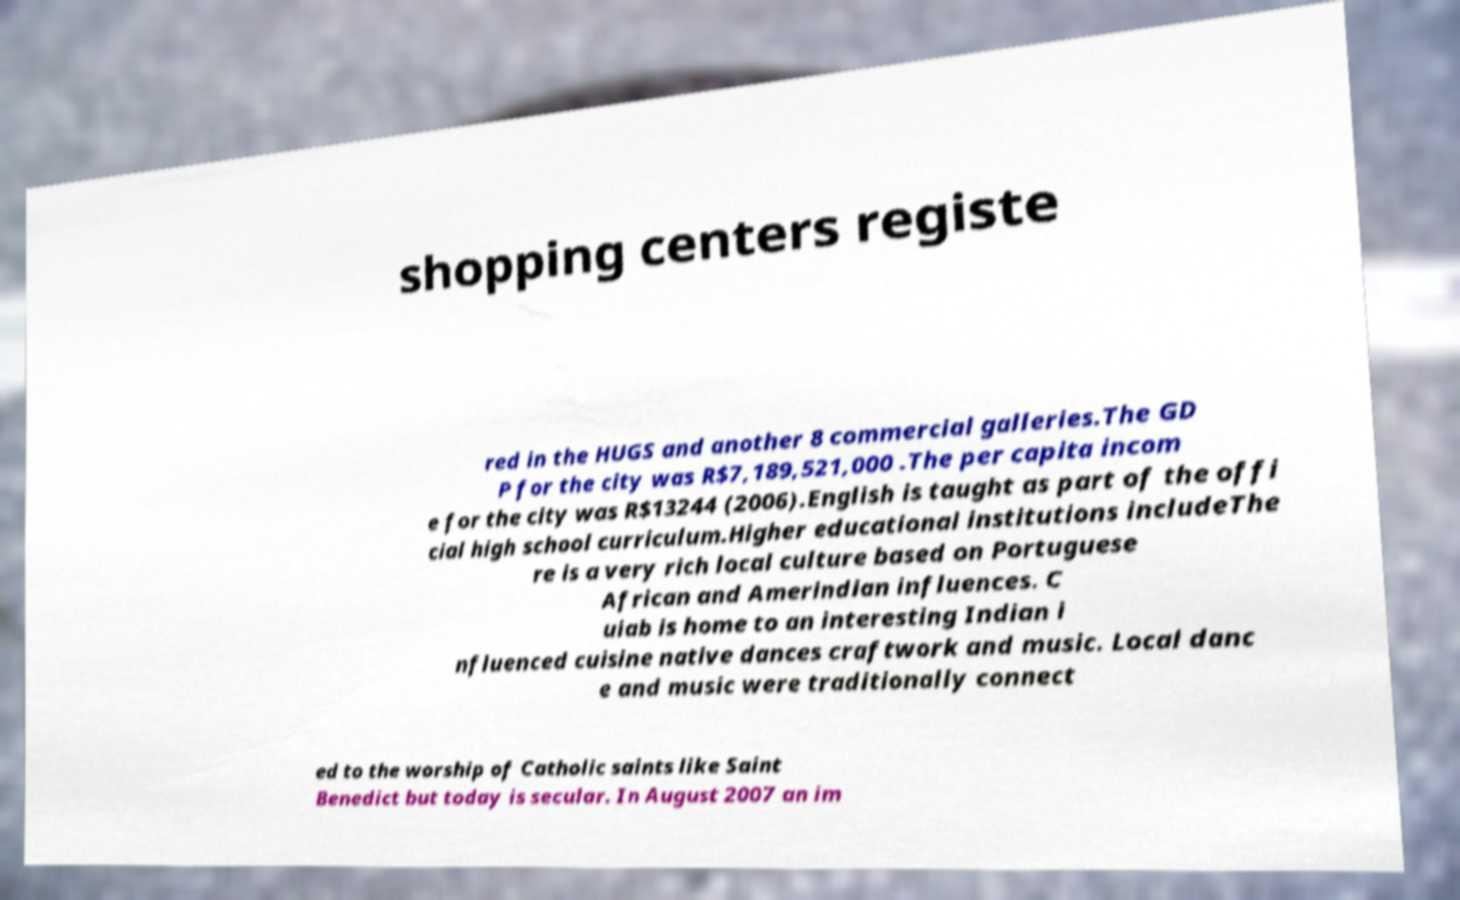There's text embedded in this image that I need extracted. Can you transcribe it verbatim? shopping centers registe red in the HUGS and another 8 commercial galleries.The GD P for the city was R$7,189,521,000 .The per capita incom e for the city was R$13244 (2006).English is taught as part of the offi cial high school curriculum.Higher educational institutions includeThe re is a very rich local culture based on Portuguese African and Amerindian influences. C uiab is home to an interesting Indian i nfluenced cuisine native dances craftwork and music. Local danc e and music were traditionally connect ed to the worship of Catholic saints like Saint Benedict but today is secular. In August 2007 an im 